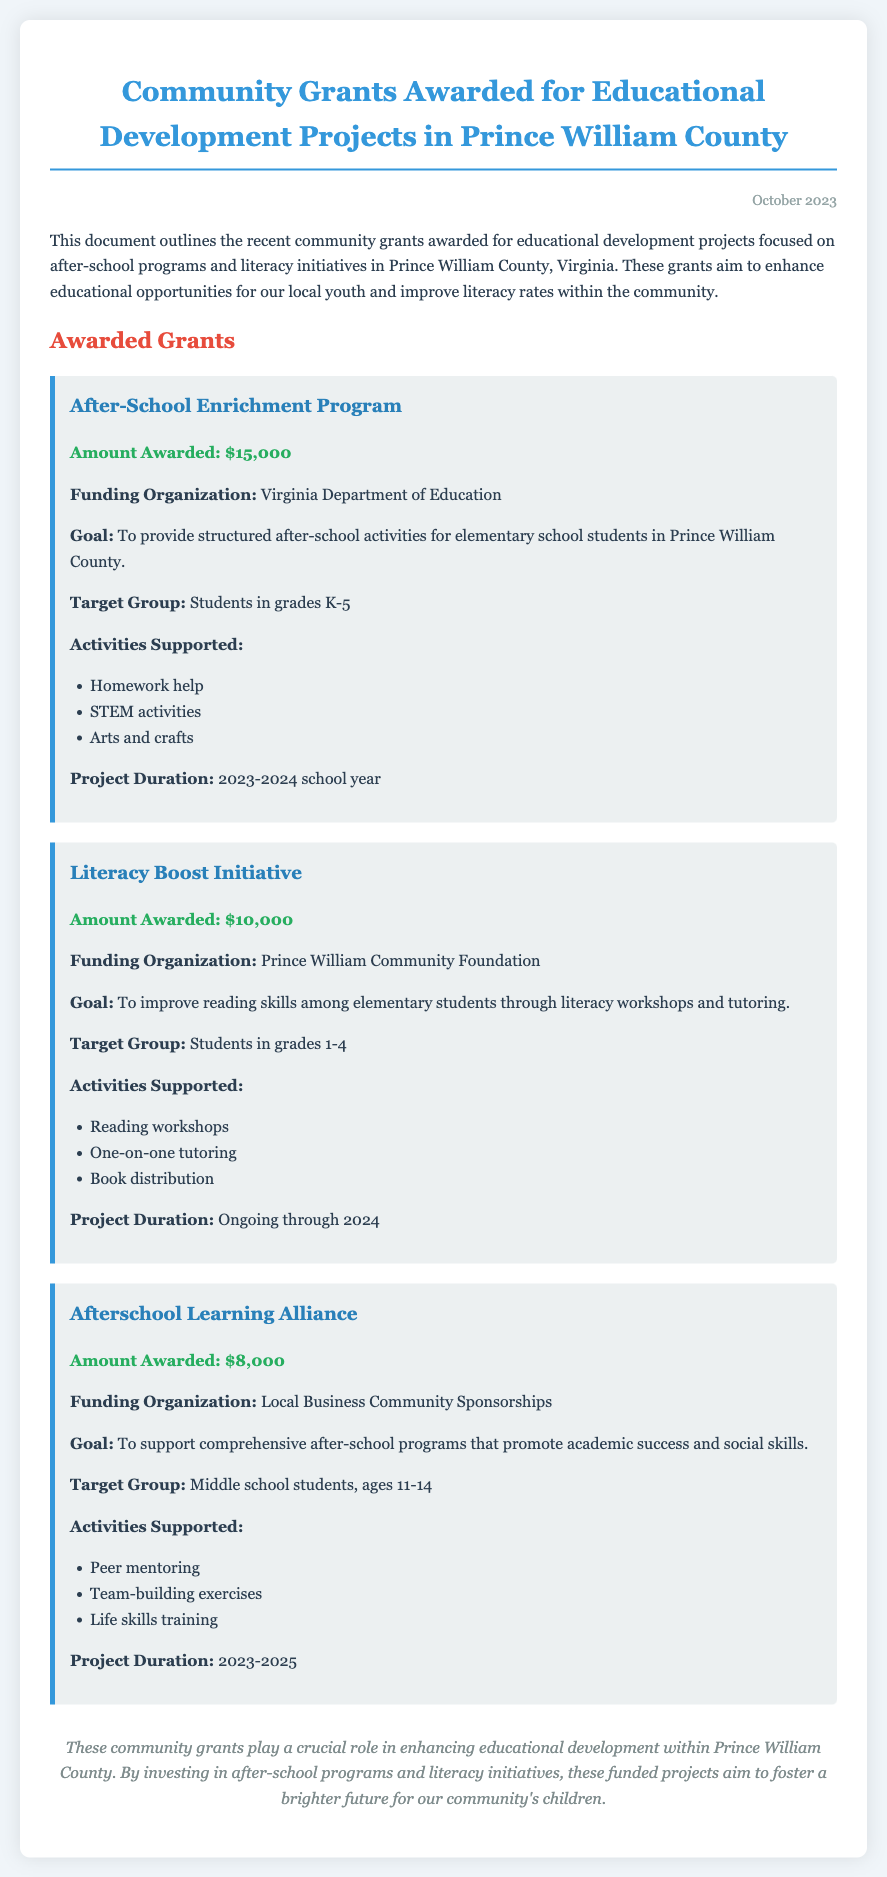What is the total amount awarded for after-school programs? The total amount awarded for after-school programs is the sum of the amounts for those projects: $15,000 + $8,000 = $23,000.
Answer: $23,000 Who funded the Literacy Boost Initiative? The funding organization for the Literacy Boost Initiative is mentioned in the document.
Answer: Prince William Community Foundation What is the target group for the After-School Enrichment Program? The target group for this program is specified in the document.
Answer: Students in grades K-5 How long will the Afterschool Learning Alliance project run? The project duration for the Afterschool Learning Alliance is indicated in the document.
Answer: 2023-2025 What activities are supported by the Literacy Boost Initiative? The document lists several activities supported by the Literacy Boost Initiative.
Answer: Reading workshops, One-on-one tutoring, Book distribution 